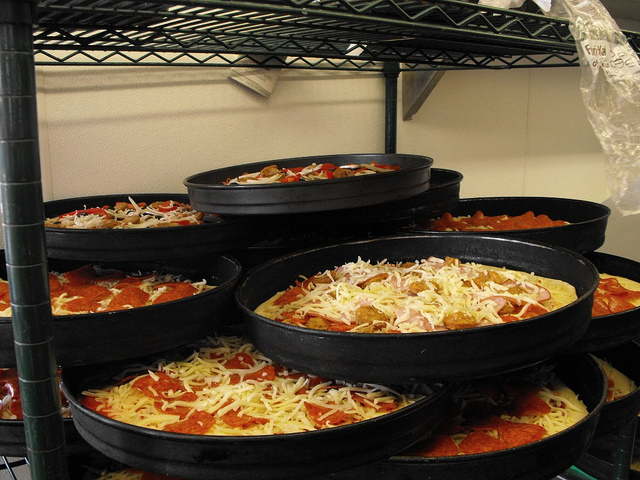Please provide a short description for this region: [0.28, 0.36, 0.68, 0.46]. This coordinate points to the highest level pizza pan in the stack, visible at the center top of the image. It holds a raw pizza, right before it gets baked, showing a vibrant layering of red sauce and white cheese. 